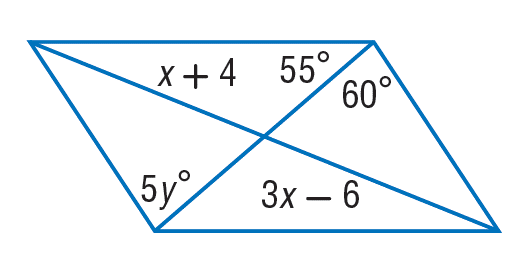Answer the mathemtical geometry problem and directly provide the correct option letter.
Question: Find y so that the quadrilateral is a parallelogram.
Choices: A: 12 B: 45 C: 55 D: 60 A 